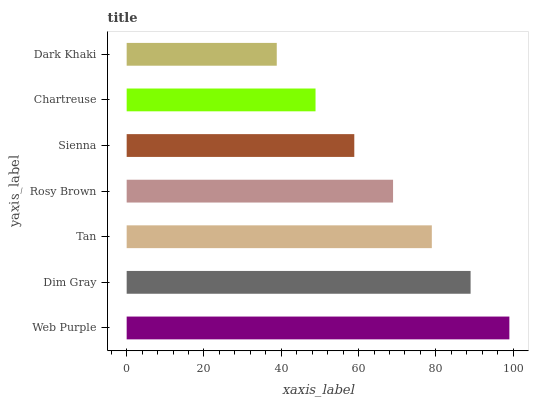Is Dark Khaki the minimum?
Answer yes or no. Yes. Is Web Purple the maximum?
Answer yes or no. Yes. Is Dim Gray the minimum?
Answer yes or no. No. Is Dim Gray the maximum?
Answer yes or no. No. Is Web Purple greater than Dim Gray?
Answer yes or no. Yes. Is Dim Gray less than Web Purple?
Answer yes or no. Yes. Is Dim Gray greater than Web Purple?
Answer yes or no. No. Is Web Purple less than Dim Gray?
Answer yes or no. No. Is Rosy Brown the high median?
Answer yes or no. Yes. Is Rosy Brown the low median?
Answer yes or no. Yes. Is Web Purple the high median?
Answer yes or no. No. Is Chartreuse the low median?
Answer yes or no. No. 